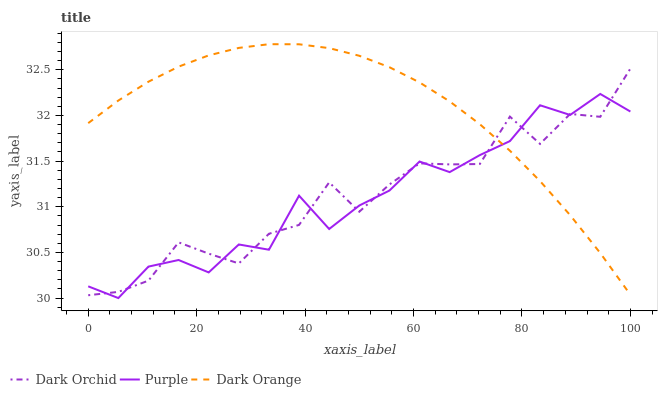Does Purple have the minimum area under the curve?
Answer yes or no. Yes. Does Dark Orange have the maximum area under the curve?
Answer yes or no. Yes. Does Dark Orchid have the minimum area under the curve?
Answer yes or no. No. Does Dark Orchid have the maximum area under the curve?
Answer yes or no. No. Is Dark Orange the smoothest?
Answer yes or no. Yes. Is Dark Orchid the roughest?
Answer yes or no. Yes. Is Dark Orchid the smoothest?
Answer yes or no. No. Is Dark Orange the roughest?
Answer yes or no. No. Does Purple have the lowest value?
Answer yes or no. Yes. Does Dark Orchid have the lowest value?
Answer yes or no. No. Does Dark Orange have the highest value?
Answer yes or no. Yes. Does Dark Orchid have the highest value?
Answer yes or no. No. Does Dark Orange intersect Purple?
Answer yes or no. Yes. Is Dark Orange less than Purple?
Answer yes or no. No. Is Dark Orange greater than Purple?
Answer yes or no. No. 